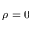<formula> <loc_0><loc_0><loc_500><loc_500>\rho = 0</formula> 